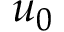<formula> <loc_0><loc_0><loc_500><loc_500>u _ { 0 }</formula> 